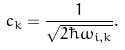<formula> <loc_0><loc_0><loc_500><loc_500>c _ { k } = \frac { 1 } { \sqrt { 2 \hbar { \omega } _ { i , { k } } } } .</formula> 